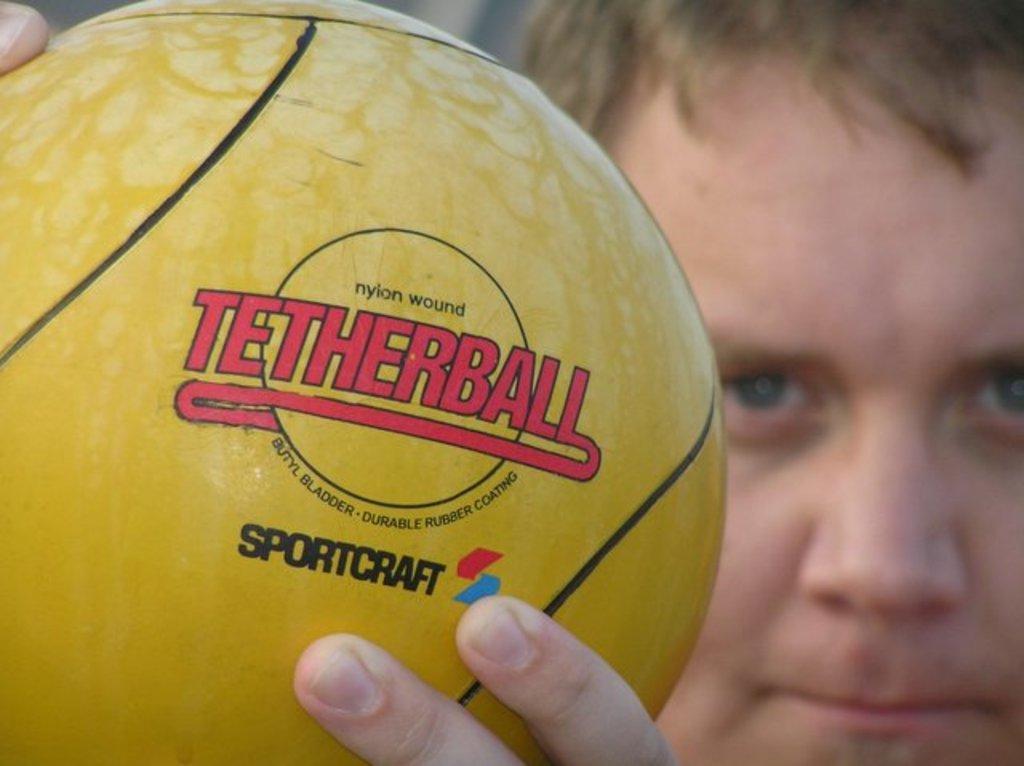Can you describe this image briefly? In this picture, i can see a person holding a ball. 